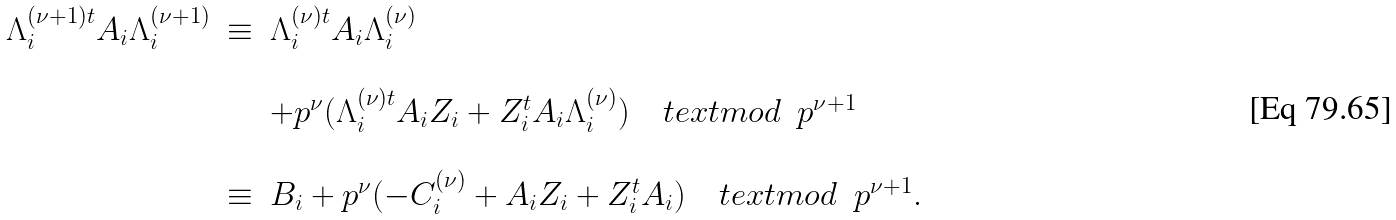<formula> <loc_0><loc_0><loc_500><loc_500>\begin{array} { r c l } \Lambda _ { i } ^ { ( \nu + 1 ) t } A _ { i } \Lambda _ { i } ^ { ( \nu + 1 ) } & \equiv & \Lambda _ { i } ^ { ( \nu ) t } A _ { i } \Lambda _ { i } ^ { ( \nu ) } \\ \ & \ & \ \\ \ & \ & + p ^ { \nu } ( \Lambda _ { i } ^ { ( \nu ) t } A _ { i } Z _ { i } + Z _ { i } ^ { t } A _ { i } \Lambda _ { i } ^ { ( \nu ) } ) \quad t e x t { m o d } \ \ p ^ { \nu + 1 } \\ \ & \ & \ \\ \ & \equiv & B _ { i } + p ^ { \nu } ( - C ^ { ( \nu ) } _ { i } + A _ { i } Z _ { i } + Z _ { i } ^ { t } A _ { i } ) \quad t e x t { m o d } \ \ p ^ { \nu + 1 } . \end{array}</formula> 